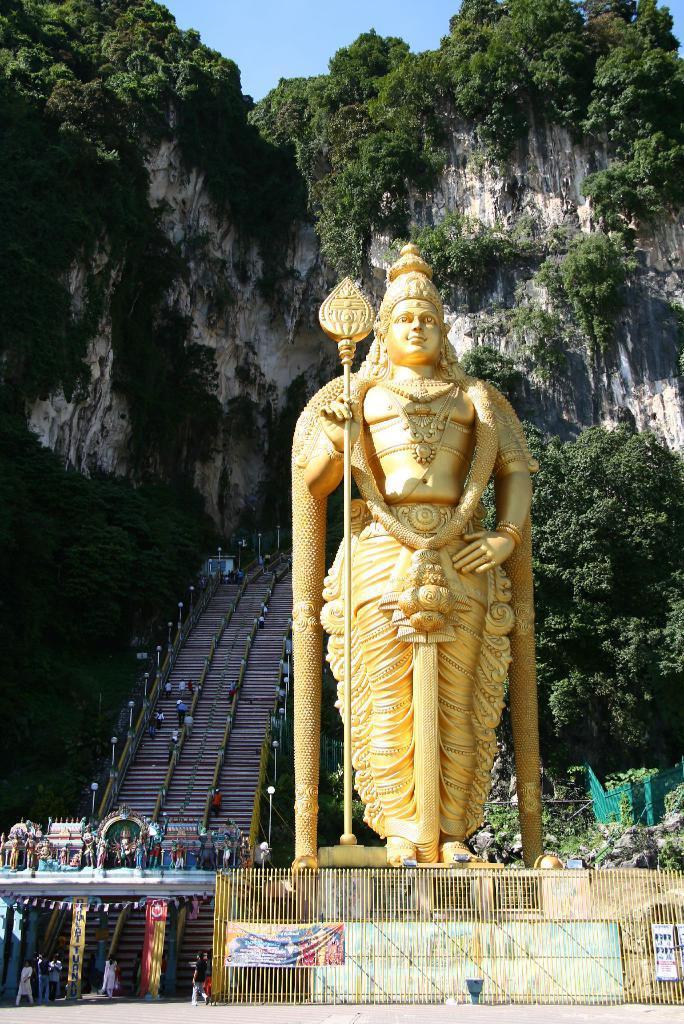How would you summarize this image in a sentence or two? In the center of the image, we can see a statue and at the bottom, there is a mesh and an arch. In the background, there are stairs, poles and we can see people. There are hills and trees. At the top, there is sky. 